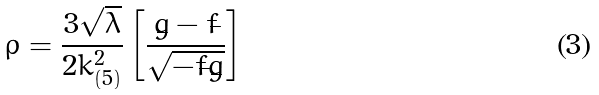Convert formula to latex. <formula><loc_0><loc_0><loc_500><loc_500>\rho = \frac { 3 \sqrt { \lambda } } { 2 k _ { ( 5 ) } ^ { 2 } } \left [ \frac { \dot { g } - \dot { f } } { \sqrt { - \dot { f } \dot { g } } } \right ]</formula> 